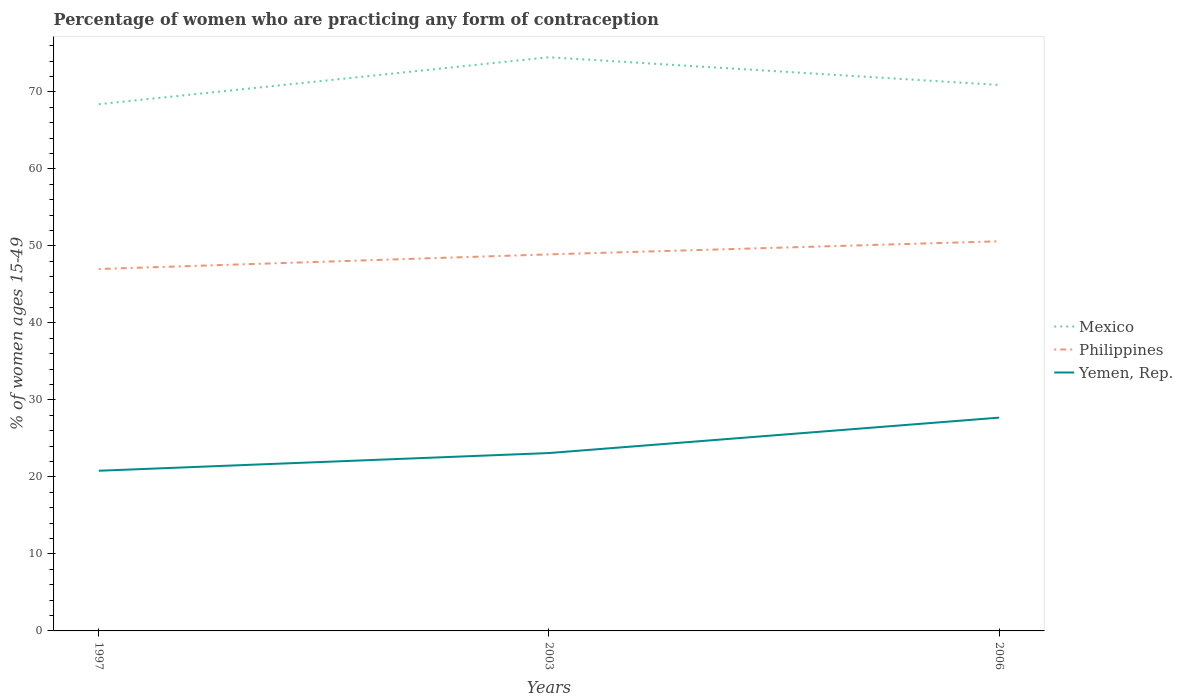How many different coloured lines are there?
Your answer should be very brief. 3. Does the line corresponding to Philippines intersect with the line corresponding to Yemen, Rep.?
Provide a short and direct response. No. Is the number of lines equal to the number of legend labels?
Provide a short and direct response. Yes. Across all years, what is the maximum percentage of women who are practicing any form of contraception in Philippines?
Your answer should be compact. 47. What is the total percentage of women who are practicing any form of contraception in Mexico in the graph?
Your answer should be very brief. 3.6. What is the difference between the highest and the second highest percentage of women who are practicing any form of contraception in Yemen, Rep.?
Give a very brief answer. 6.9. What is the difference between the highest and the lowest percentage of women who are practicing any form of contraception in Philippines?
Your answer should be compact. 2. How many lines are there?
Your answer should be compact. 3. Does the graph contain grids?
Provide a short and direct response. No. Where does the legend appear in the graph?
Keep it short and to the point. Center right. How many legend labels are there?
Give a very brief answer. 3. How are the legend labels stacked?
Ensure brevity in your answer.  Vertical. What is the title of the graph?
Your answer should be very brief. Percentage of women who are practicing any form of contraception. Does "South Asia" appear as one of the legend labels in the graph?
Your response must be concise. No. What is the label or title of the Y-axis?
Ensure brevity in your answer.  % of women ages 15-49. What is the % of women ages 15-49 of Mexico in 1997?
Your answer should be compact. 68.4. What is the % of women ages 15-49 of Yemen, Rep. in 1997?
Make the answer very short. 20.8. What is the % of women ages 15-49 in Mexico in 2003?
Ensure brevity in your answer.  74.5. What is the % of women ages 15-49 in Philippines in 2003?
Ensure brevity in your answer.  48.9. What is the % of women ages 15-49 of Yemen, Rep. in 2003?
Provide a short and direct response. 23.1. What is the % of women ages 15-49 of Mexico in 2006?
Your answer should be compact. 70.9. What is the % of women ages 15-49 of Philippines in 2006?
Make the answer very short. 50.6. What is the % of women ages 15-49 of Yemen, Rep. in 2006?
Give a very brief answer. 27.7. Across all years, what is the maximum % of women ages 15-49 of Mexico?
Make the answer very short. 74.5. Across all years, what is the maximum % of women ages 15-49 in Philippines?
Keep it short and to the point. 50.6. Across all years, what is the maximum % of women ages 15-49 in Yemen, Rep.?
Offer a very short reply. 27.7. Across all years, what is the minimum % of women ages 15-49 in Mexico?
Your answer should be very brief. 68.4. Across all years, what is the minimum % of women ages 15-49 in Philippines?
Your answer should be compact. 47. Across all years, what is the minimum % of women ages 15-49 in Yemen, Rep.?
Your answer should be very brief. 20.8. What is the total % of women ages 15-49 in Mexico in the graph?
Your answer should be compact. 213.8. What is the total % of women ages 15-49 of Philippines in the graph?
Your answer should be very brief. 146.5. What is the total % of women ages 15-49 of Yemen, Rep. in the graph?
Offer a very short reply. 71.6. What is the difference between the % of women ages 15-49 in Mexico in 1997 and that in 2003?
Keep it short and to the point. -6.1. What is the difference between the % of women ages 15-49 in Yemen, Rep. in 1997 and that in 2006?
Your answer should be compact. -6.9. What is the difference between the % of women ages 15-49 in Mexico in 2003 and that in 2006?
Ensure brevity in your answer.  3.6. What is the difference between the % of women ages 15-49 of Mexico in 1997 and the % of women ages 15-49 of Yemen, Rep. in 2003?
Your response must be concise. 45.3. What is the difference between the % of women ages 15-49 in Philippines in 1997 and the % of women ages 15-49 in Yemen, Rep. in 2003?
Your answer should be compact. 23.9. What is the difference between the % of women ages 15-49 in Mexico in 1997 and the % of women ages 15-49 in Philippines in 2006?
Your answer should be compact. 17.8. What is the difference between the % of women ages 15-49 in Mexico in 1997 and the % of women ages 15-49 in Yemen, Rep. in 2006?
Your response must be concise. 40.7. What is the difference between the % of women ages 15-49 of Philippines in 1997 and the % of women ages 15-49 of Yemen, Rep. in 2006?
Ensure brevity in your answer.  19.3. What is the difference between the % of women ages 15-49 in Mexico in 2003 and the % of women ages 15-49 in Philippines in 2006?
Your response must be concise. 23.9. What is the difference between the % of women ages 15-49 of Mexico in 2003 and the % of women ages 15-49 of Yemen, Rep. in 2006?
Offer a terse response. 46.8. What is the difference between the % of women ages 15-49 of Philippines in 2003 and the % of women ages 15-49 of Yemen, Rep. in 2006?
Provide a short and direct response. 21.2. What is the average % of women ages 15-49 in Mexico per year?
Provide a succinct answer. 71.27. What is the average % of women ages 15-49 in Philippines per year?
Your response must be concise. 48.83. What is the average % of women ages 15-49 of Yemen, Rep. per year?
Keep it short and to the point. 23.87. In the year 1997, what is the difference between the % of women ages 15-49 in Mexico and % of women ages 15-49 in Philippines?
Your answer should be very brief. 21.4. In the year 1997, what is the difference between the % of women ages 15-49 in Mexico and % of women ages 15-49 in Yemen, Rep.?
Give a very brief answer. 47.6. In the year 1997, what is the difference between the % of women ages 15-49 of Philippines and % of women ages 15-49 of Yemen, Rep.?
Provide a succinct answer. 26.2. In the year 2003, what is the difference between the % of women ages 15-49 of Mexico and % of women ages 15-49 of Philippines?
Your answer should be compact. 25.6. In the year 2003, what is the difference between the % of women ages 15-49 of Mexico and % of women ages 15-49 of Yemen, Rep.?
Your response must be concise. 51.4. In the year 2003, what is the difference between the % of women ages 15-49 in Philippines and % of women ages 15-49 in Yemen, Rep.?
Keep it short and to the point. 25.8. In the year 2006, what is the difference between the % of women ages 15-49 of Mexico and % of women ages 15-49 of Philippines?
Your response must be concise. 20.3. In the year 2006, what is the difference between the % of women ages 15-49 in Mexico and % of women ages 15-49 in Yemen, Rep.?
Offer a very short reply. 43.2. In the year 2006, what is the difference between the % of women ages 15-49 in Philippines and % of women ages 15-49 in Yemen, Rep.?
Offer a terse response. 22.9. What is the ratio of the % of women ages 15-49 in Mexico in 1997 to that in 2003?
Ensure brevity in your answer.  0.92. What is the ratio of the % of women ages 15-49 of Philippines in 1997 to that in 2003?
Your response must be concise. 0.96. What is the ratio of the % of women ages 15-49 in Yemen, Rep. in 1997 to that in 2003?
Make the answer very short. 0.9. What is the ratio of the % of women ages 15-49 in Mexico in 1997 to that in 2006?
Your answer should be compact. 0.96. What is the ratio of the % of women ages 15-49 of Philippines in 1997 to that in 2006?
Provide a short and direct response. 0.93. What is the ratio of the % of women ages 15-49 of Yemen, Rep. in 1997 to that in 2006?
Offer a terse response. 0.75. What is the ratio of the % of women ages 15-49 in Mexico in 2003 to that in 2006?
Ensure brevity in your answer.  1.05. What is the ratio of the % of women ages 15-49 in Philippines in 2003 to that in 2006?
Ensure brevity in your answer.  0.97. What is the ratio of the % of women ages 15-49 of Yemen, Rep. in 2003 to that in 2006?
Provide a short and direct response. 0.83. What is the difference between the highest and the second highest % of women ages 15-49 of Yemen, Rep.?
Provide a short and direct response. 4.6. What is the difference between the highest and the lowest % of women ages 15-49 in Mexico?
Your response must be concise. 6.1. What is the difference between the highest and the lowest % of women ages 15-49 in Philippines?
Offer a very short reply. 3.6. 